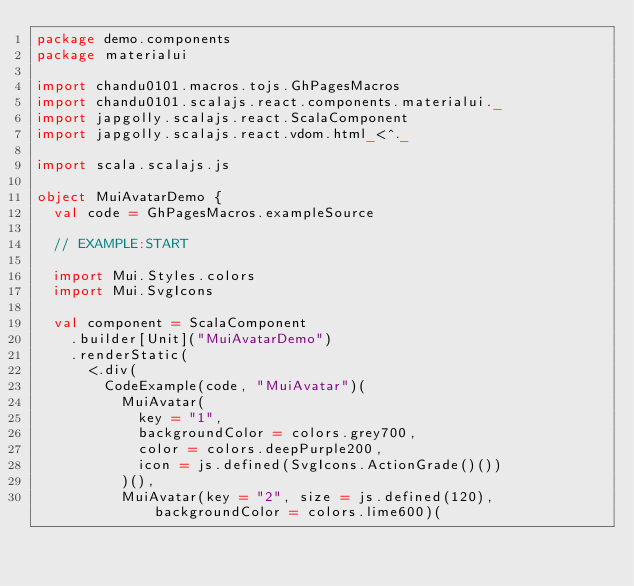<code> <loc_0><loc_0><loc_500><loc_500><_Scala_>package demo.components
package materialui

import chandu0101.macros.tojs.GhPagesMacros
import chandu0101.scalajs.react.components.materialui._
import japgolly.scalajs.react.ScalaComponent
import japgolly.scalajs.react.vdom.html_<^._

import scala.scalajs.js

object MuiAvatarDemo {
  val code = GhPagesMacros.exampleSource

  // EXAMPLE:START

  import Mui.Styles.colors
  import Mui.SvgIcons

  val component = ScalaComponent
    .builder[Unit]("MuiAvatarDemo")
    .renderStatic(
      <.div(
        CodeExample(code, "MuiAvatar")(
          MuiAvatar(
            key = "1",
            backgroundColor = colors.grey700,
            color = colors.deepPurple200,
            icon = js.defined(SvgIcons.ActionGrade()())
          )(),
          MuiAvatar(key = "2", size = js.defined(120), backgroundColor = colors.lime600)(</code> 